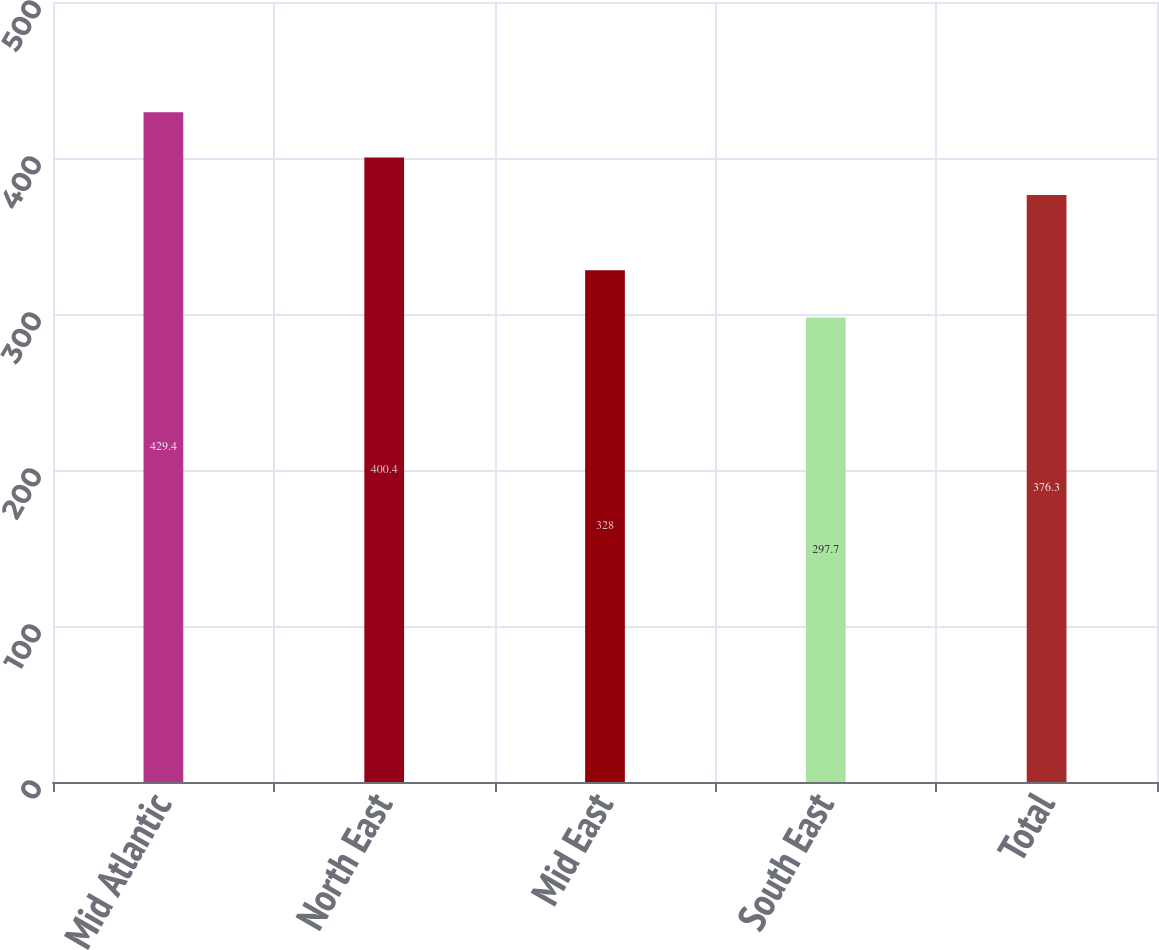Convert chart. <chart><loc_0><loc_0><loc_500><loc_500><bar_chart><fcel>Mid Atlantic<fcel>North East<fcel>Mid East<fcel>South East<fcel>Total<nl><fcel>429.4<fcel>400.4<fcel>328<fcel>297.7<fcel>376.3<nl></chart> 